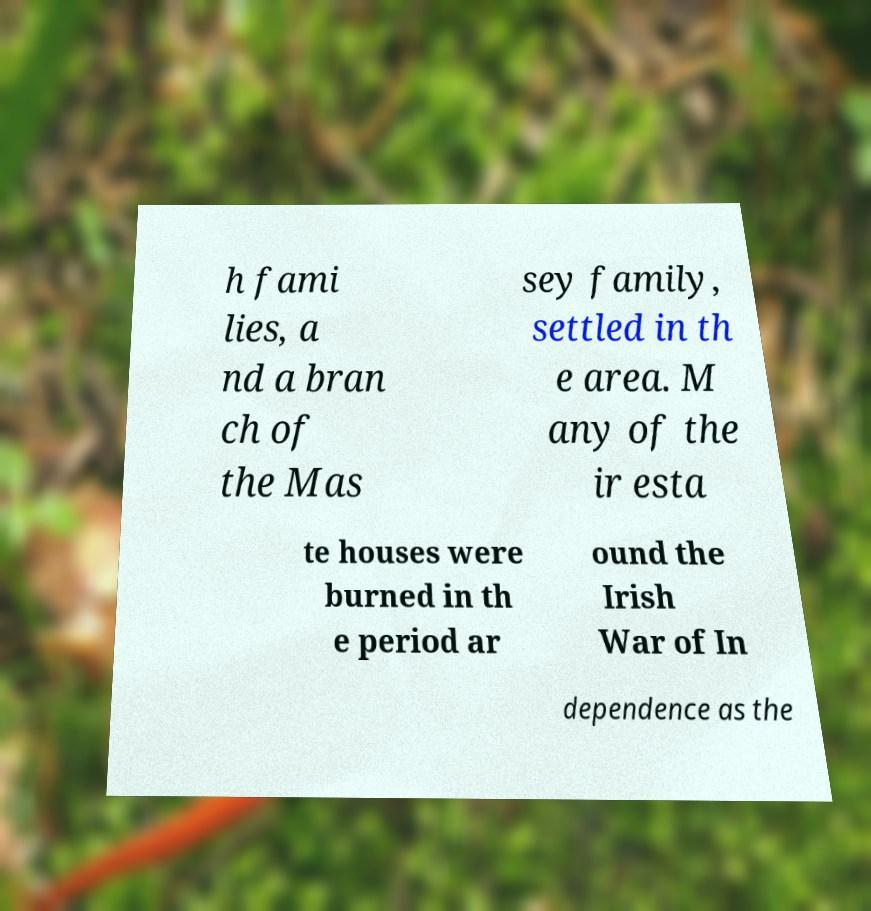Please identify and transcribe the text found in this image. h fami lies, a nd a bran ch of the Mas sey family, settled in th e area. M any of the ir esta te houses were burned in th e period ar ound the Irish War of In dependence as the 